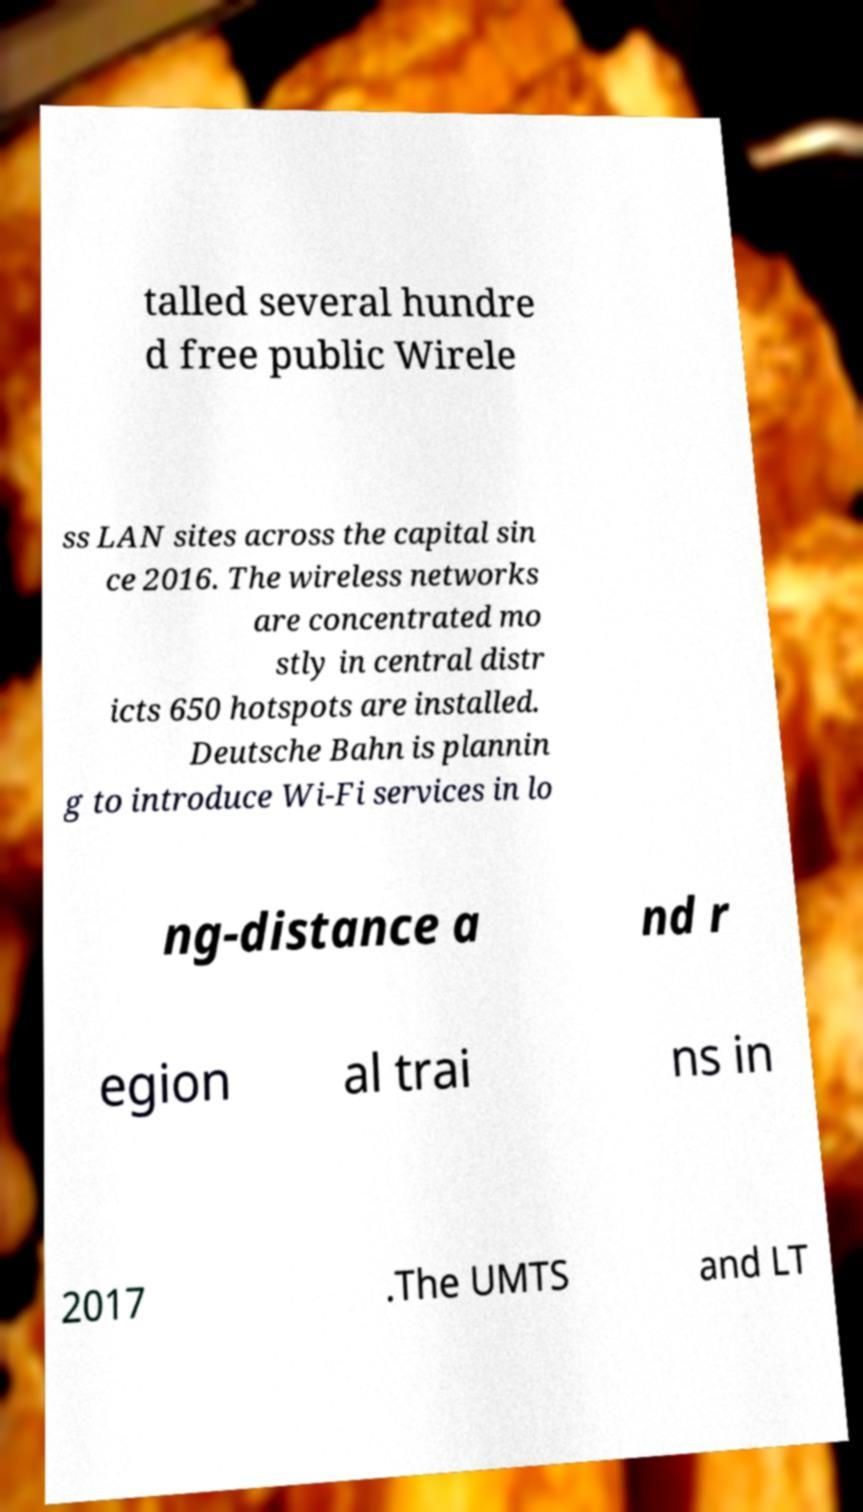For documentation purposes, I need the text within this image transcribed. Could you provide that? talled several hundre d free public Wirele ss LAN sites across the capital sin ce 2016. The wireless networks are concentrated mo stly in central distr icts 650 hotspots are installed. Deutsche Bahn is plannin g to introduce Wi-Fi services in lo ng-distance a nd r egion al trai ns in 2017 .The UMTS and LT 